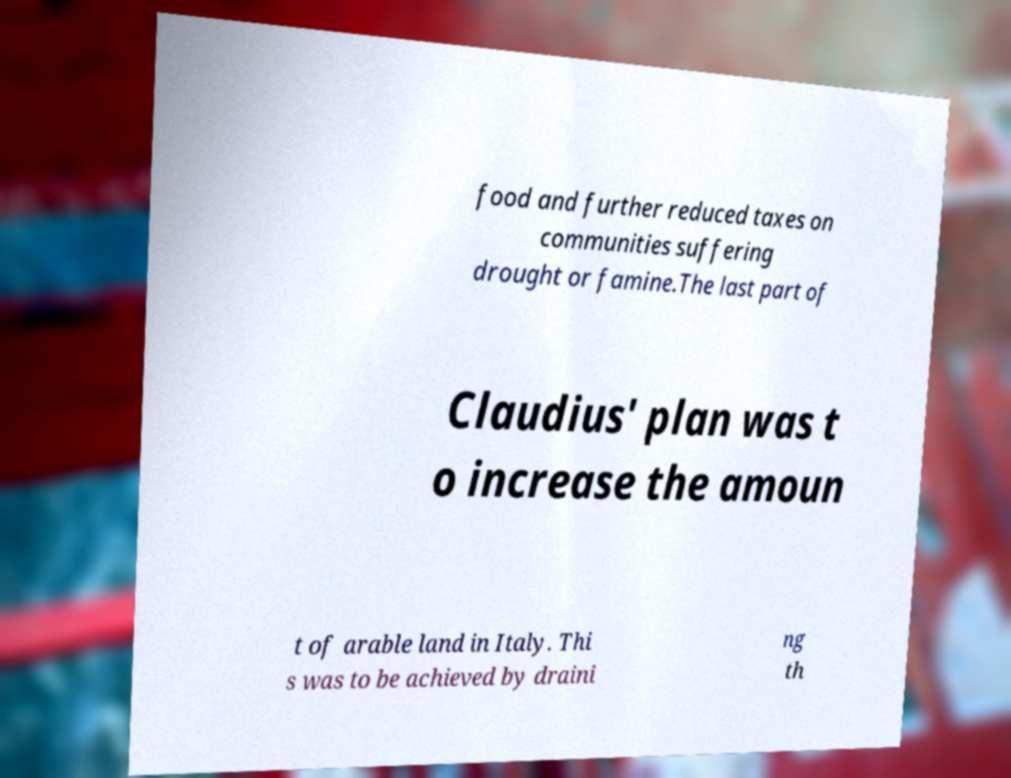There's text embedded in this image that I need extracted. Can you transcribe it verbatim? food and further reduced taxes on communities suffering drought or famine.The last part of Claudius' plan was t o increase the amoun t of arable land in Italy. Thi s was to be achieved by draini ng th 